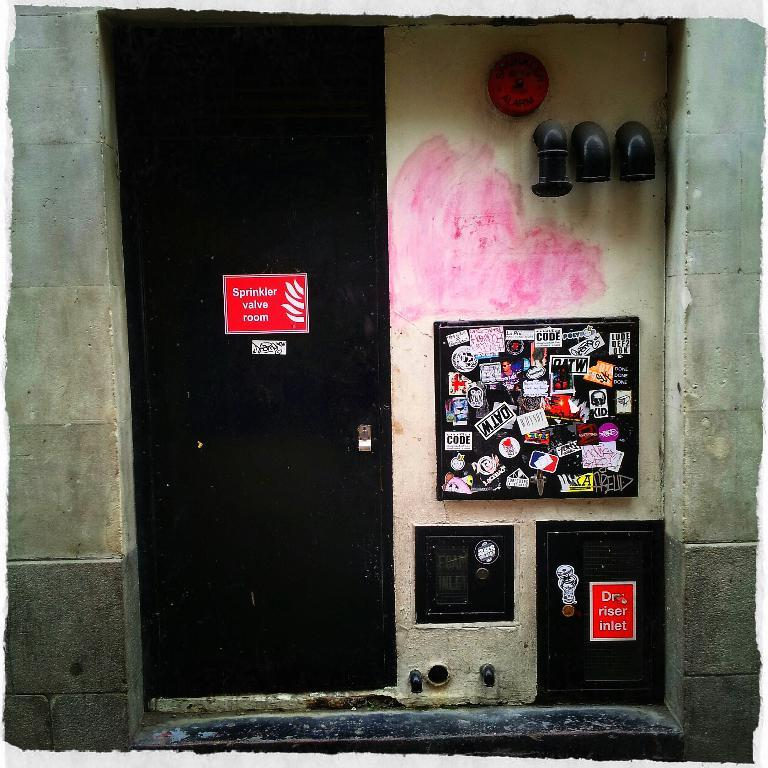What type of structure can be seen in the image? There is a wall in the image. Is there any entrance visible in the image? Yes, there is a door in the image. What is the color of the door? The door is black. What other object can be seen in the image? There is a board in the image. What is attached to the wall in the image? There are pipes attached to the wall in the image. What type of glass is used to make the door in the image? There is no glass used to make the door in the image; it is a black door made of solid material. 